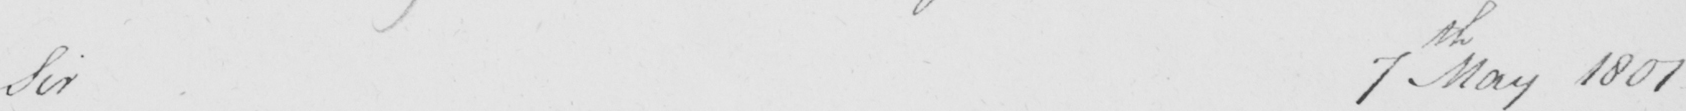Can you read and transcribe this handwriting? Sir 7th May 1801 _ 